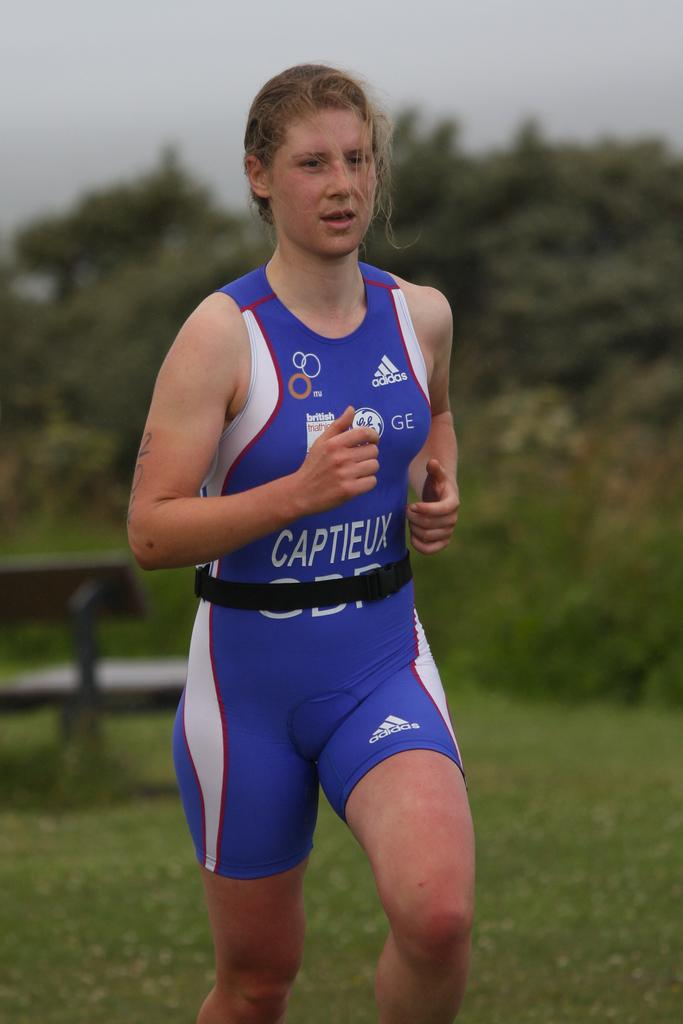<image>
Summarize the visual content of the image. The advertiser on the shirt is from Adidas 